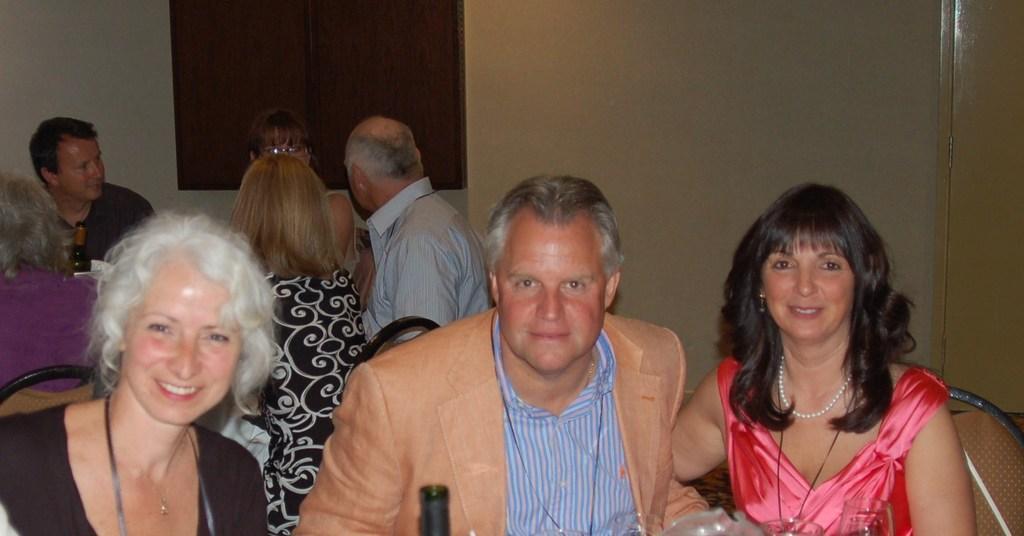How would you summarize this image in a sentence or two? In this image we can see people sitting on chairs. In the background of the image there is a wall. There is a window. To the right side of the image there is a door. 